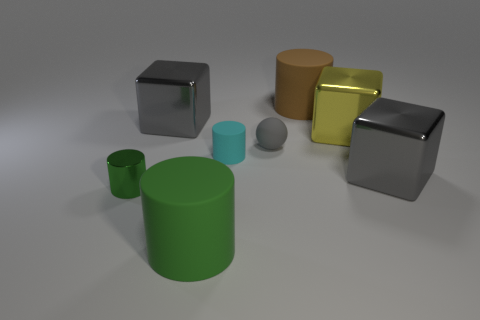What is the color of the tiny metal cylinder?
Provide a short and direct response. Green. There is a cylinder in front of the green metal thing; does it have the same size as the cyan matte thing that is left of the tiny gray ball?
Offer a very short reply. No. How big is the metallic thing that is both left of the large brown matte cylinder and in front of the small gray sphere?
Offer a terse response. Small. What color is the small metal object that is the same shape as the large green rubber object?
Offer a very short reply. Green. Are there more green things on the left side of the gray sphere than rubber spheres that are left of the large green cylinder?
Give a very brief answer. Yes. How many other things are the same shape as the yellow metallic thing?
Your response must be concise. 2. There is a gray thing right of the gray matte object; is there a small thing behind it?
Offer a very short reply. Yes. What number of large cyan blocks are there?
Provide a succinct answer. 0. There is a small matte ball; does it have the same color as the large metallic thing that is left of the small gray thing?
Your response must be concise. Yes. Is the number of big cylinders greater than the number of rubber cylinders?
Make the answer very short. No. 